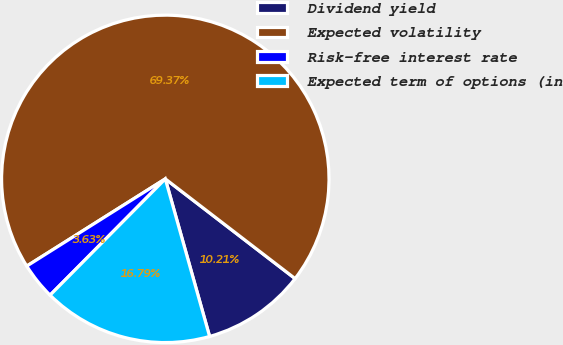Convert chart. <chart><loc_0><loc_0><loc_500><loc_500><pie_chart><fcel>Dividend yield<fcel>Expected volatility<fcel>Risk-free interest rate<fcel>Expected term of options (in<nl><fcel>10.21%<fcel>69.37%<fcel>3.63%<fcel>16.79%<nl></chart> 